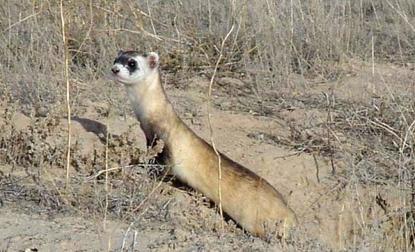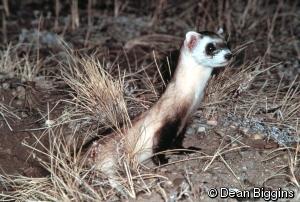The first image is the image on the left, the second image is the image on the right. Given the left and right images, does the statement "There are two black footed ferrets standing in the dirt in the center of the images." hold true? Answer yes or no. Yes. 